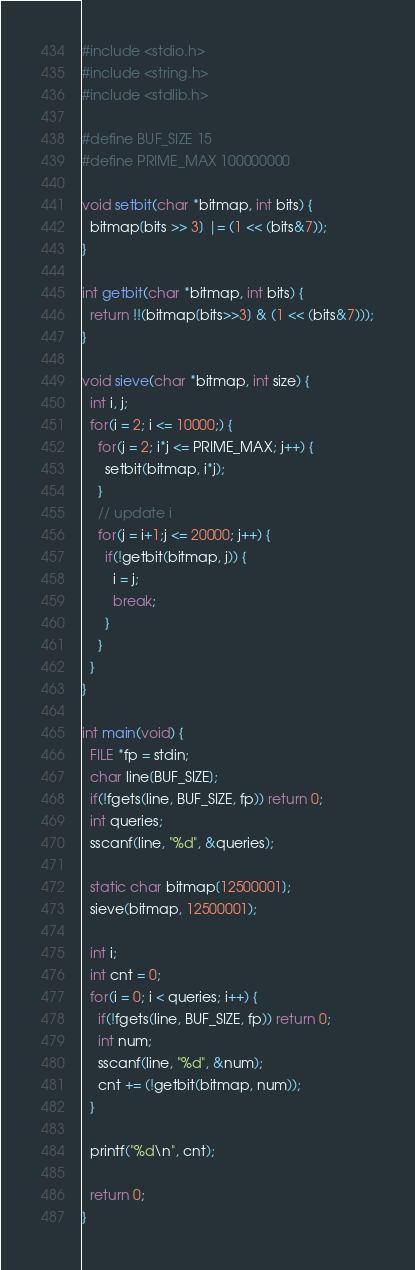<code> <loc_0><loc_0><loc_500><loc_500><_C_>#include <stdio.h>
#include <string.h>
#include <stdlib.h>

#define BUF_SIZE 15
#define PRIME_MAX 100000000

void setbit(char *bitmap, int bits) {
  bitmap[bits >> 3] |= (1 << (bits&7));
}

int getbit(char *bitmap, int bits) {
  return !!(bitmap[bits>>3] & (1 << (bits&7)));
}

void sieve(char *bitmap, int size) {
  int i, j;
  for(i = 2; i <= 10000;) {
    for(j = 2; i*j <= PRIME_MAX; j++) {
      setbit(bitmap, i*j);
    }
    // update i
    for(j = i+1;j <= 20000; j++) {
      if(!getbit(bitmap, j)) {
        i = j;
        break;
      }
    }
  }
}

int main(void) {
  FILE *fp = stdin;
  char line[BUF_SIZE];
  if(!fgets(line, BUF_SIZE, fp)) return 0;
  int queries;
  sscanf(line, "%d", &queries);

  static char bitmap[12500001];
  sieve(bitmap, 12500001);

  int i;
  int cnt = 0;
  for(i = 0; i < queries; i++) {
    if(!fgets(line, BUF_SIZE, fp)) return 0;
    int num;
    sscanf(line, "%d", &num);
    cnt += (!getbit(bitmap, num));
  }

  printf("%d\n", cnt);

  return 0;
}
</code> 